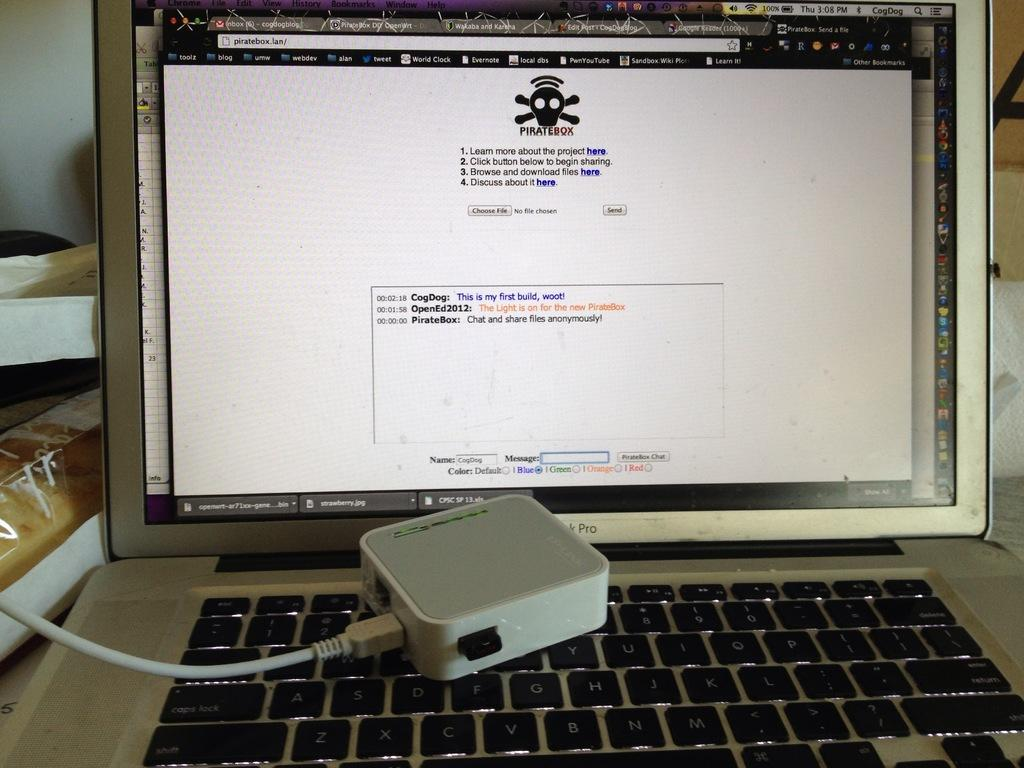<image>
Relay a brief, clear account of the picture shown. A computer has a PirateBox window open and a device sitting on the keyboard. 